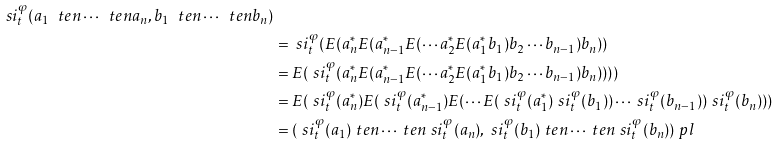Convert formula to latex. <formula><loc_0><loc_0><loc_500><loc_500>{ \ s i _ { t } ^ { \varphi } ( a _ { 1 } \ t e n \cdots \ t e n a _ { n } , b _ { 1 } \ t e n \cdots \ t e n b _ { n } ) } \\ & = \ s i _ { t } ^ { \varphi } ( E ( a _ { n } ^ { * } E ( a _ { n - 1 } ^ { * } E ( \cdots a _ { 2 } ^ { * } E ( a _ { 1 } ^ { * } b _ { 1 } ) b _ { 2 } \cdots b _ { n - 1 } ) b _ { n } ) ) \\ & = E ( \ s i _ { t } ^ { \varphi } ( a _ { n } ^ { * } E ( a _ { n - 1 } ^ { * } E ( \cdots a _ { 2 } ^ { * } E ( a _ { 1 } ^ { * } b _ { 1 } ) b _ { 2 } \cdots b _ { n - 1 } ) b _ { n } ) ) ) ) \\ & = E ( \ s i _ { t } ^ { \varphi } ( a _ { n } ^ { * } ) E ( \ s i _ { t } ^ { \varphi } ( a _ { n - 1 } ^ { * } ) E ( \cdots E ( \ s i _ { t } ^ { \varphi } ( a _ { 1 } ^ { * } ) \ s i _ { t } ^ { \varphi } ( b _ { 1 } ) ) \cdots \ s i _ { t } ^ { \varphi } ( b _ { n - 1 } ) ) \ s i _ { t } ^ { \varphi } ( b _ { n } ) ) ) \\ & = ( \ s i _ { t } ^ { \varphi } ( a _ { 1 } ) \ t e n \cdots \ t e n \ s i _ { t } ^ { \varphi } ( a _ { n } ) , \ s i _ { t } ^ { \varphi } ( b _ { 1 } ) \ t e n \cdots \ t e n \ s i _ { t } ^ { \varphi } ( b _ { n } ) ) \ p l</formula> 